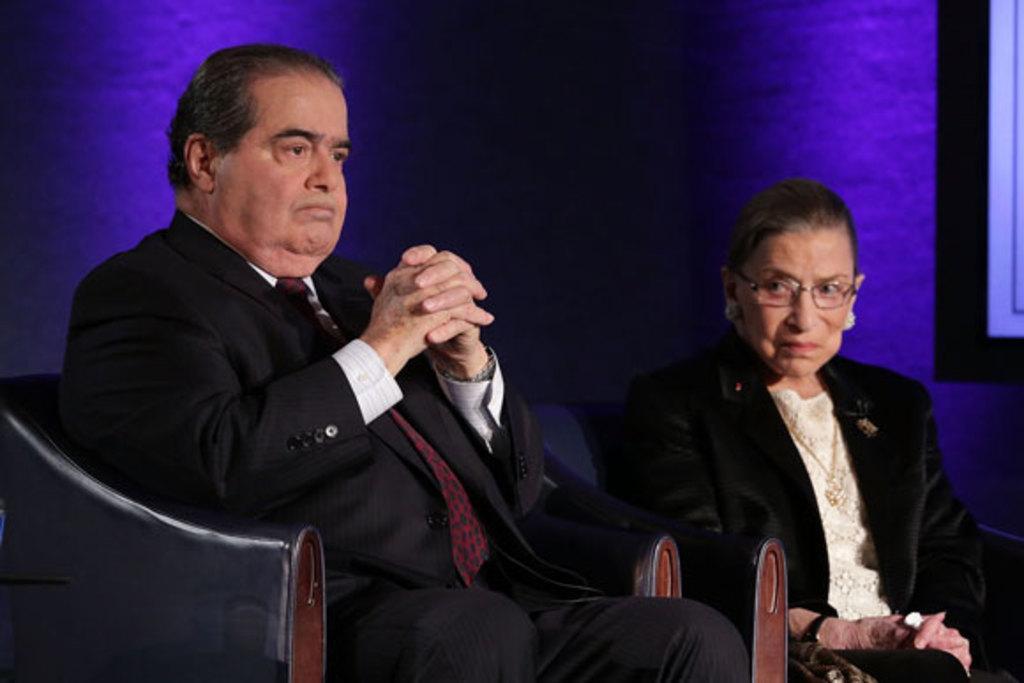Can you describe this image briefly? In this image there is a man and a woman sitting on chairs, in the background it is in blue color. 